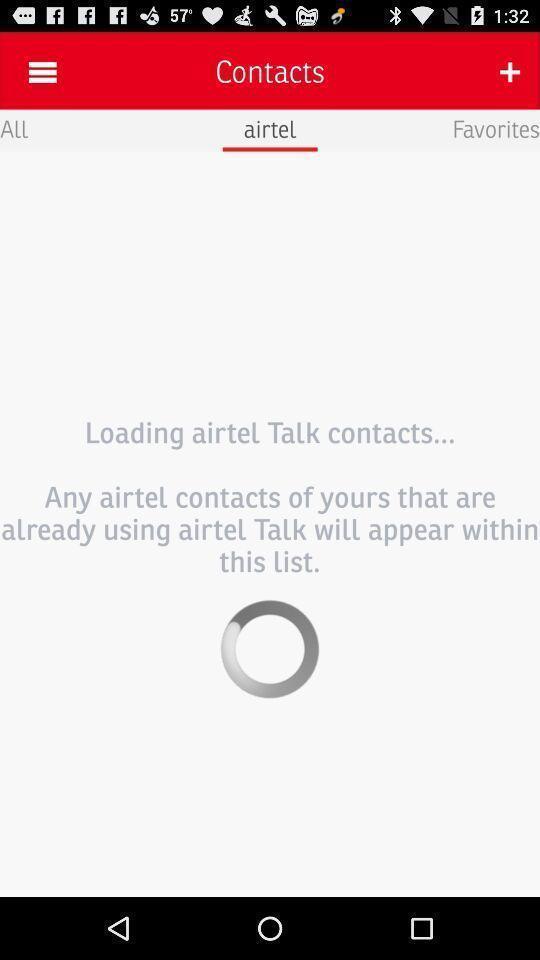Tell me what you see in this picture. Page of a telecom company. 